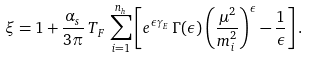Convert formula to latex. <formula><loc_0><loc_0><loc_500><loc_500>\xi = 1 + \frac { \alpha _ { s } } { 3 \pi } \, T _ { F } \, \sum _ { i = 1 } ^ { n _ { h } } \left [ e ^ { \epsilon \gamma _ { E } } \, \Gamma ( \epsilon ) \left ( \frac { \mu ^ { 2 } } { m _ { i } ^ { 2 } } \right ) ^ { \epsilon } - \frac { 1 } { \epsilon } \right ] .</formula> 